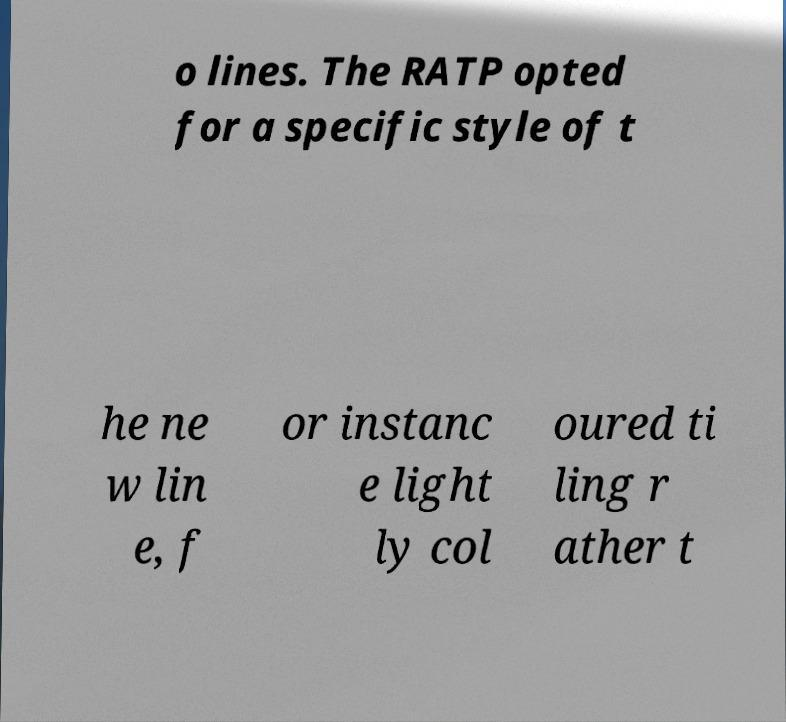Could you assist in decoding the text presented in this image and type it out clearly? o lines. The RATP opted for a specific style of t he ne w lin e, f or instanc e light ly col oured ti ling r ather t 